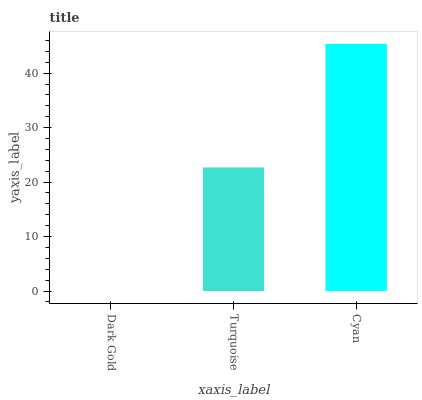Is Dark Gold the minimum?
Answer yes or no. Yes. Is Cyan the maximum?
Answer yes or no. Yes. Is Turquoise the minimum?
Answer yes or no. No. Is Turquoise the maximum?
Answer yes or no. No. Is Turquoise greater than Dark Gold?
Answer yes or no. Yes. Is Dark Gold less than Turquoise?
Answer yes or no. Yes. Is Dark Gold greater than Turquoise?
Answer yes or no. No. Is Turquoise less than Dark Gold?
Answer yes or no. No. Is Turquoise the high median?
Answer yes or no. Yes. Is Turquoise the low median?
Answer yes or no. Yes. Is Dark Gold the high median?
Answer yes or no. No. Is Cyan the low median?
Answer yes or no. No. 